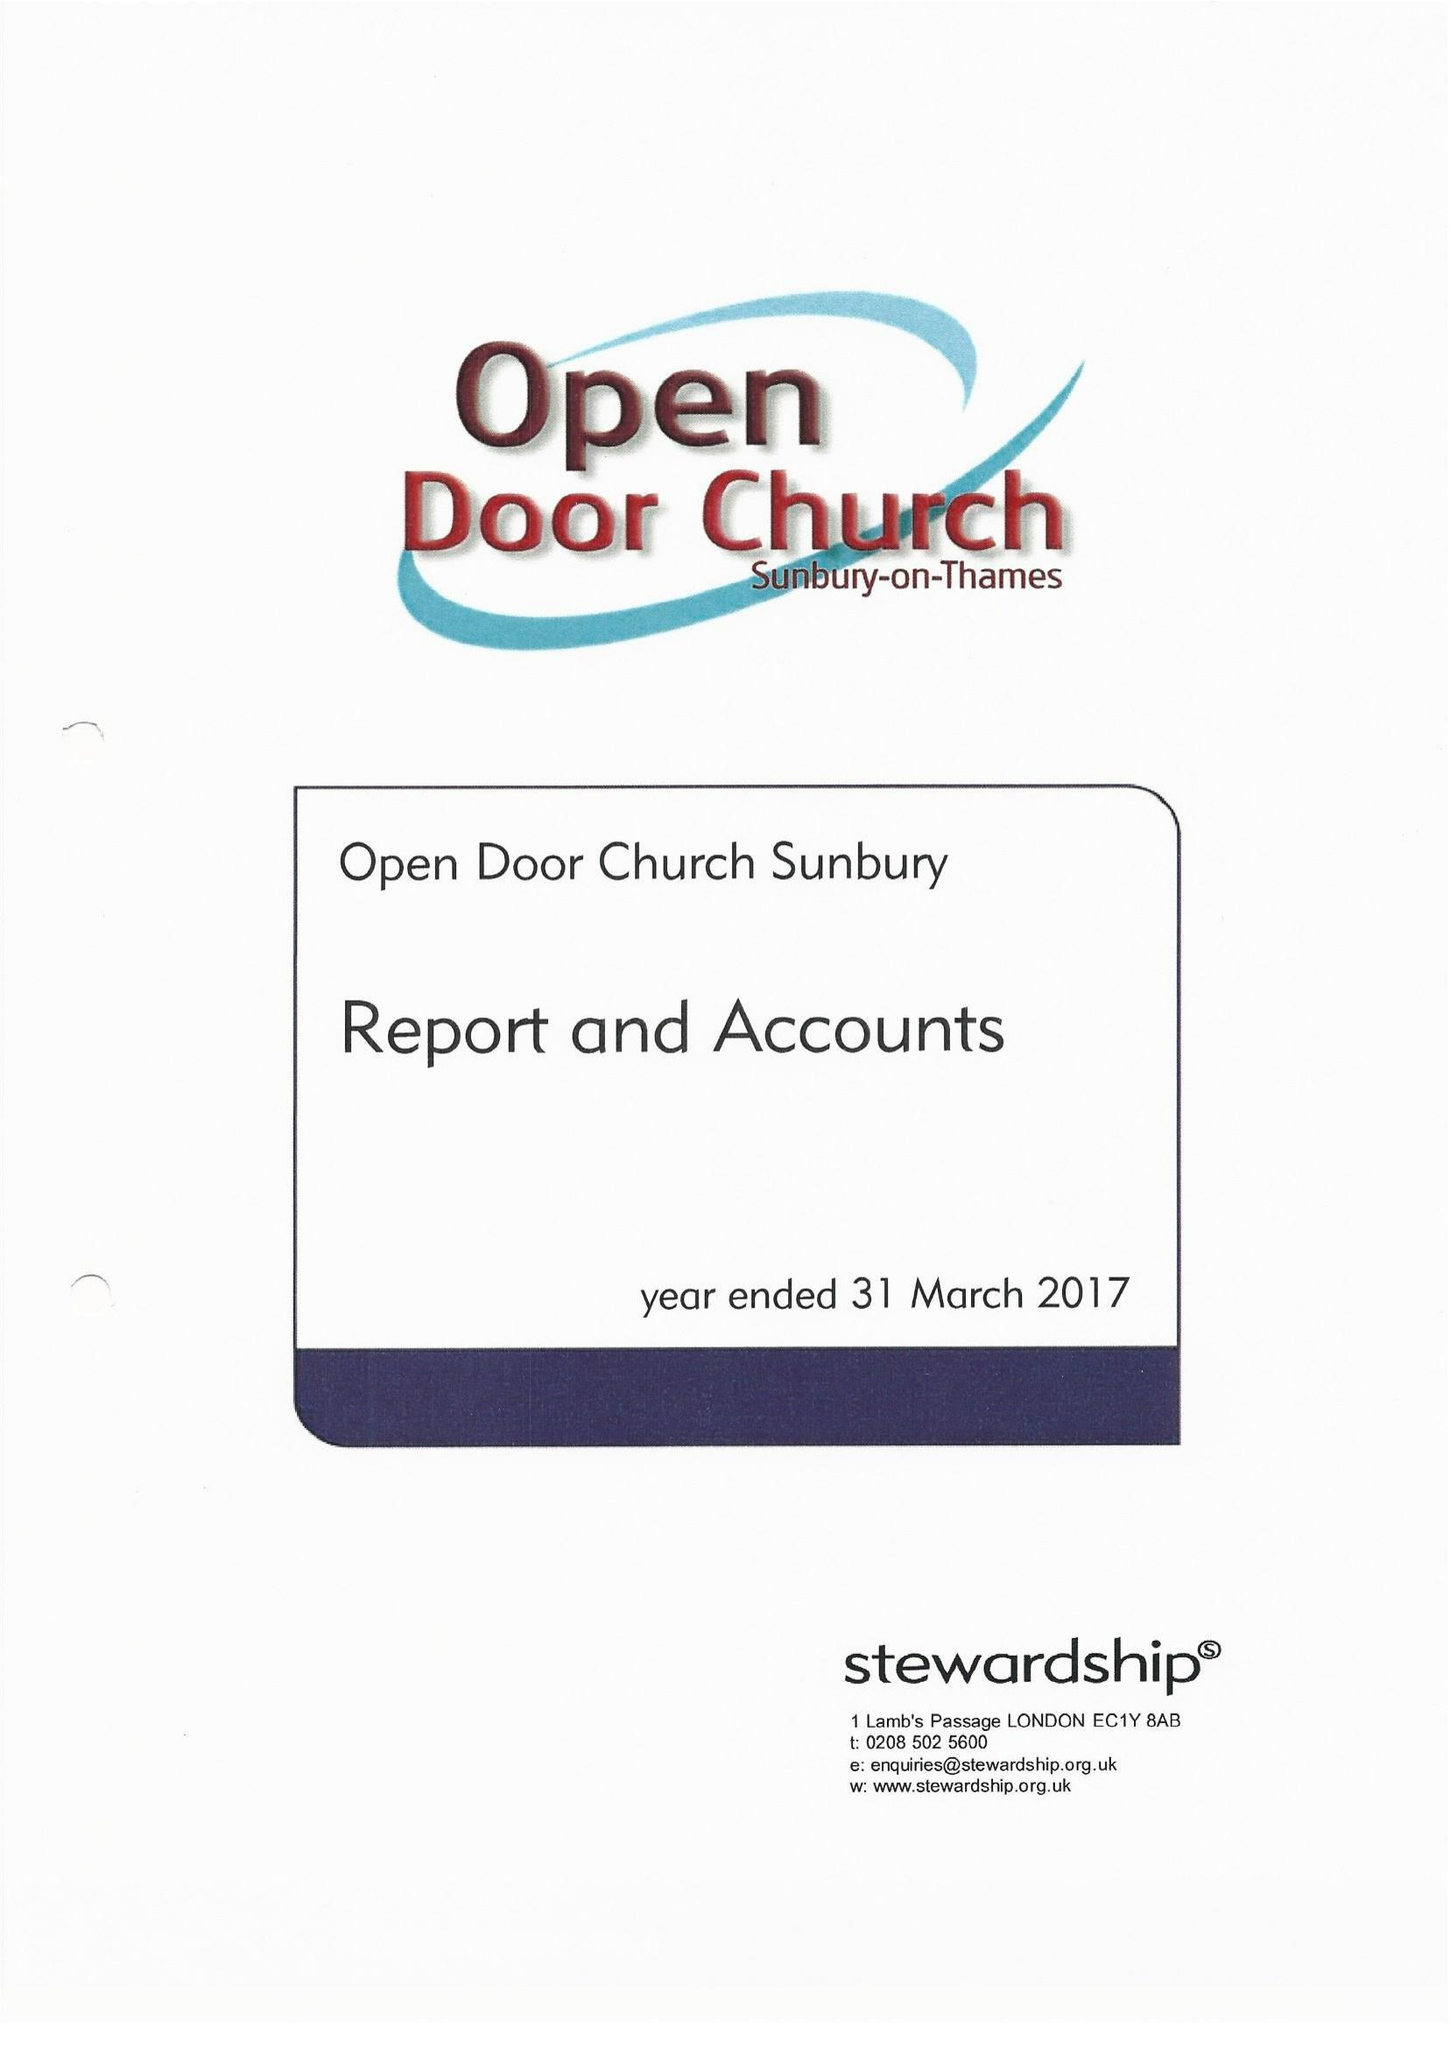What is the value for the charity_name?
Answer the question using a single word or phrase. Open Door Church Sunbury 